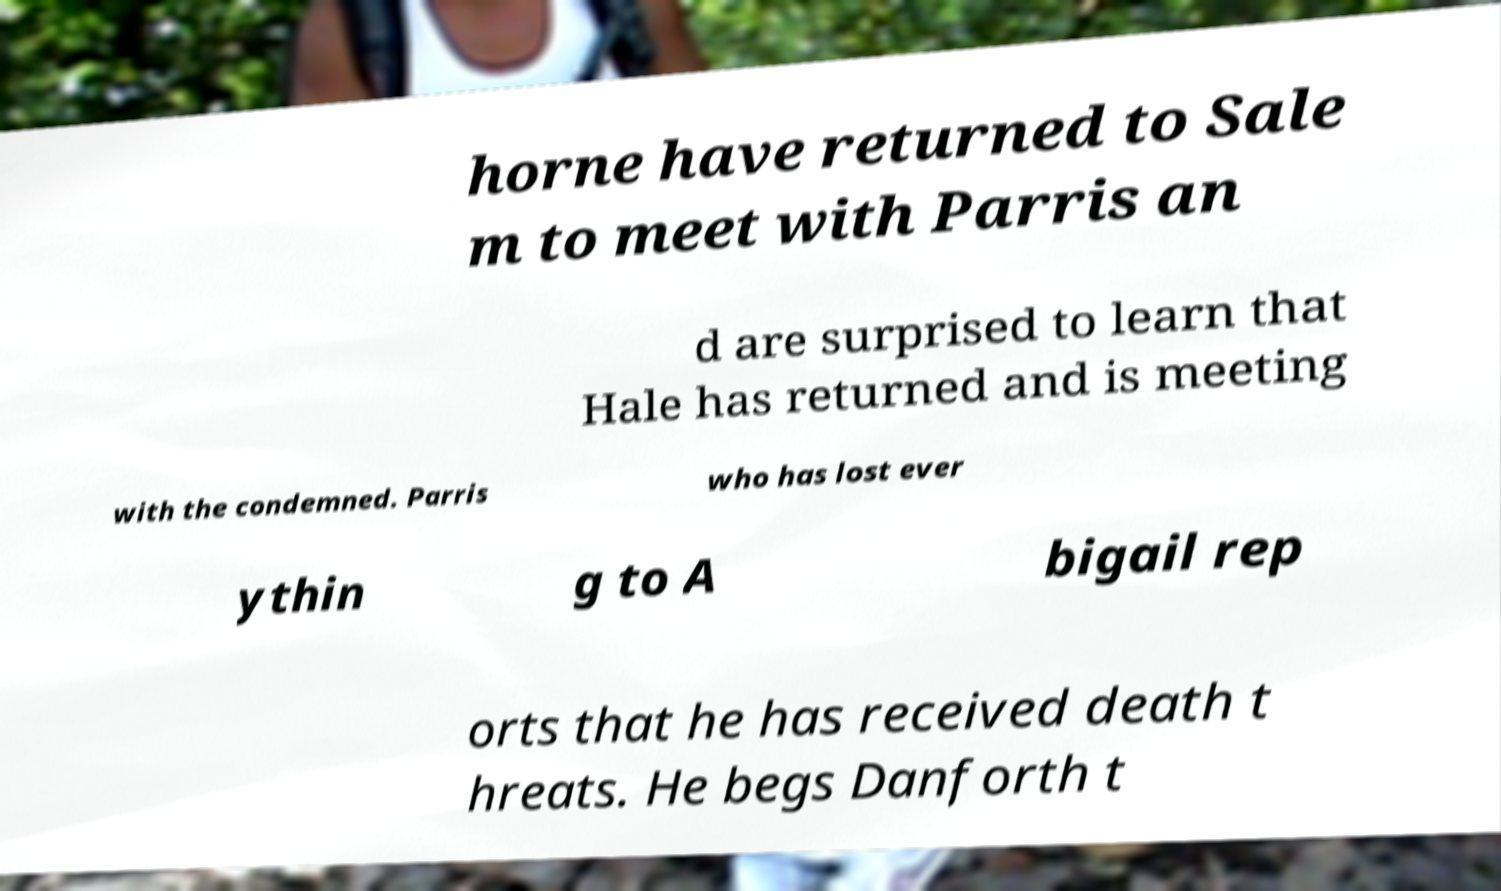Please read and relay the text visible in this image. What does it say? horne have returned to Sale m to meet with Parris an d are surprised to learn that Hale has returned and is meeting with the condemned. Parris who has lost ever ythin g to A bigail rep orts that he has received death t hreats. He begs Danforth t 